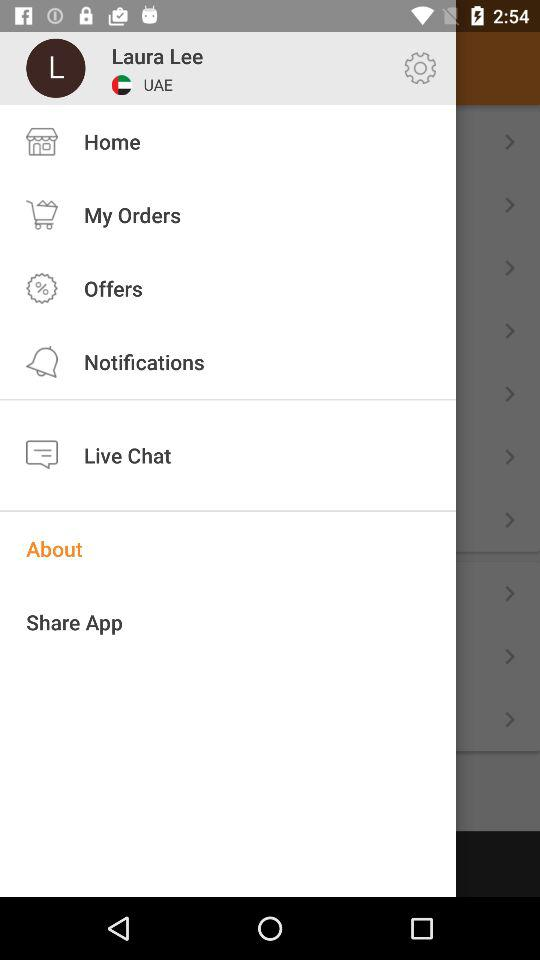What is the profile name? The profile name is Laura Lee. 